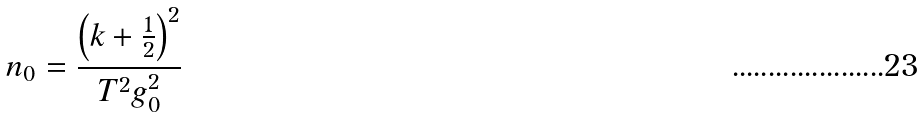Convert formula to latex. <formula><loc_0><loc_0><loc_500><loc_500>n _ { 0 } = \frac { \left ( k + \frac { 1 } { 2 } \right ) ^ { 2 } } { T ^ { 2 } g _ { 0 } ^ { 2 } }</formula> 